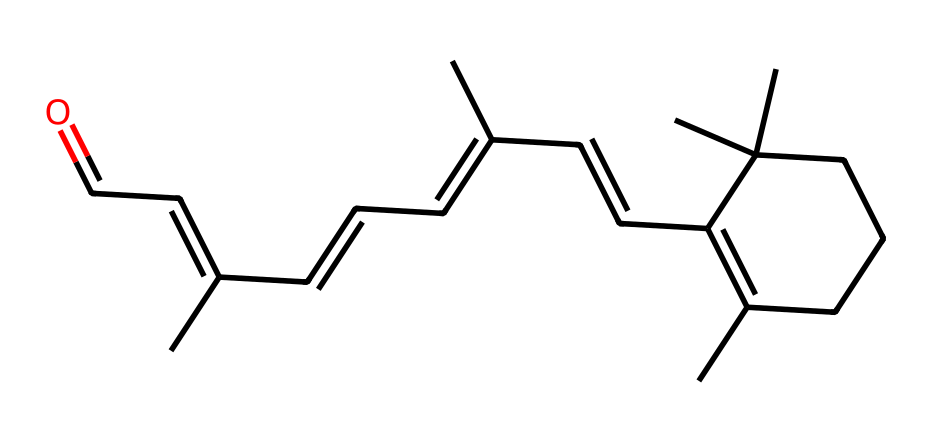What is the molecular formula of retinol? Analyzing the SMILES representation provides information on the number of carbon (C), hydrogen (H), and oxygen (O) atoms. Counting the carbon atoms gives 20, hydrogen atoms gives 30, and oxygen atoms gives 1. Thus, the molecular formula is C20H30O.
Answer: C20H30O How many double bonds are present in retinol? The structure can be examined through the SMILES notation for double bonds. Each "=" indicates a double bond, and by counting these in the provided SMILES representation, we find there are 6 double bonds.
Answer: 6 What is the primary functional group in retinol? The SMILES structure shows the presence of a carbonyl group (C=O) at the end of the carbon chain, which helps identify it as an aldehyde. This functional group is essential for its biochemical activity.
Answer: aldehyde Does retinol contain any rings in its structure? By observing the structure indicated in the SMILES notation, the "C1" designates the start of a ring system, and other "C" shows how many connections it forms with the same atom. There is one cyclohexene ring present.
Answer: Yes How does the number of methyl groups affect retinol's properties? The presence of multiple methyl groups, which are identified in the notation as "C", contributes to influencing the hydrophobicity and stability of retinol. Each methyl group adds to the overall hydrophobic character.
Answer: Increases hydrophobicity Identify if retinol is a saturated or unsaturated compound. The presence of double bonds indicated by "=" in the SMILES representation confirms that there are unsaturations. Therefore, we classify retinol as an unsaturated compound due to the presence of multiple double bonds.
Answer: Unsaturated 